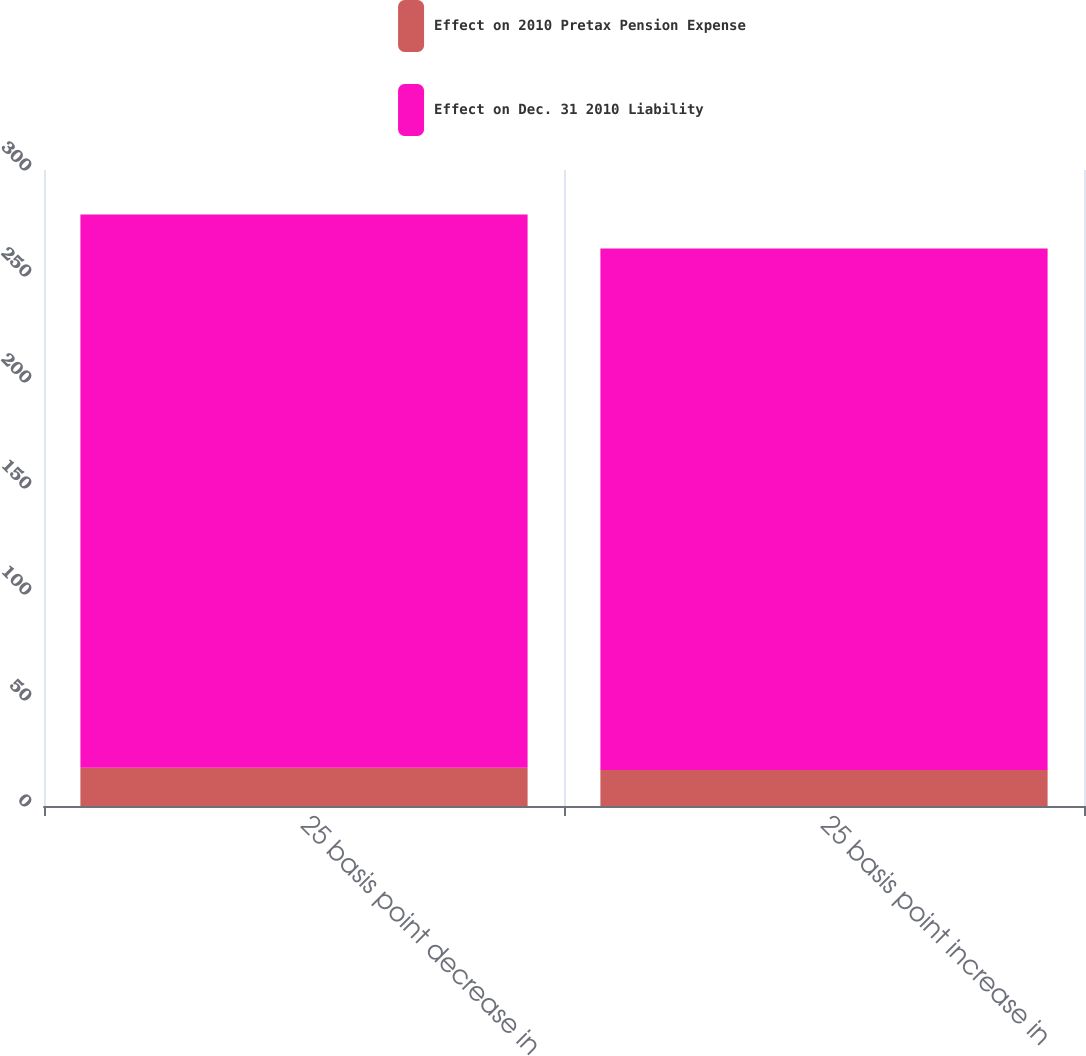Convert chart to OTSL. <chart><loc_0><loc_0><loc_500><loc_500><stacked_bar_chart><ecel><fcel>25 basis point decrease in<fcel>25 basis point increase in<nl><fcel>Effect on 2010 Pretax Pension Expense<fcel>18<fcel>17<nl><fcel>Effect on Dec. 31 2010 Liability<fcel>261<fcel>246<nl></chart> 